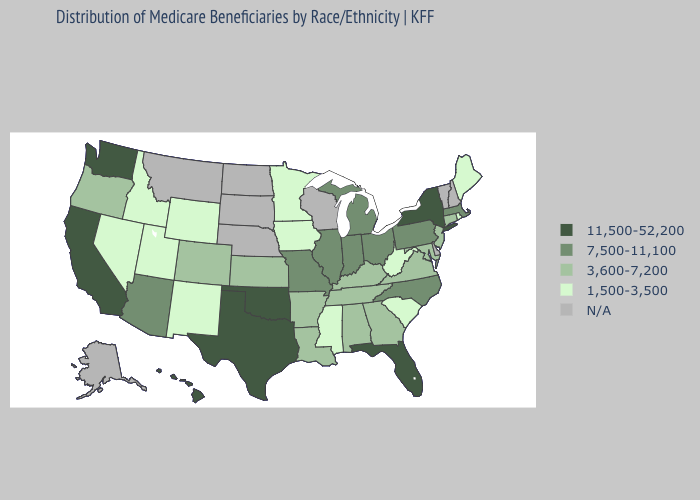Among the states that border Wyoming , which have the lowest value?
Quick response, please. Idaho, Utah. What is the highest value in the South ?
Answer briefly. 11,500-52,200. Does the map have missing data?
Keep it brief. Yes. What is the lowest value in states that border Delaware?
Answer briefly. 3,600-7,200. What is the value of West Virginia?
Be succinct. 1,500-3,500. What is the value of Minnesota?
Write a very short answer. 1,500-3,500. Does the first symbol in the legend represent the smallest category?
Keep it brief. No. What is the value of North Carolina?
Short answer required. 7,500-11,100. Name the states that have a value in the range 7,500-11,100?
Short answer required. Arizona, Illinois, Indiana, Massachusetts, Michigan, Missouri, North Carolina, Ohio, Pennsylvania. Does Hawaii have the highest value in the West?
Give a very brief answer. Yes. What is the value of California?
Answer briefly. 11,500-52,200. What is the highest value in the USA?
Be succinct. 11,500-52,200. What is the lowest value in the Northeast?
Quick response, please. 1,500-3,500. 